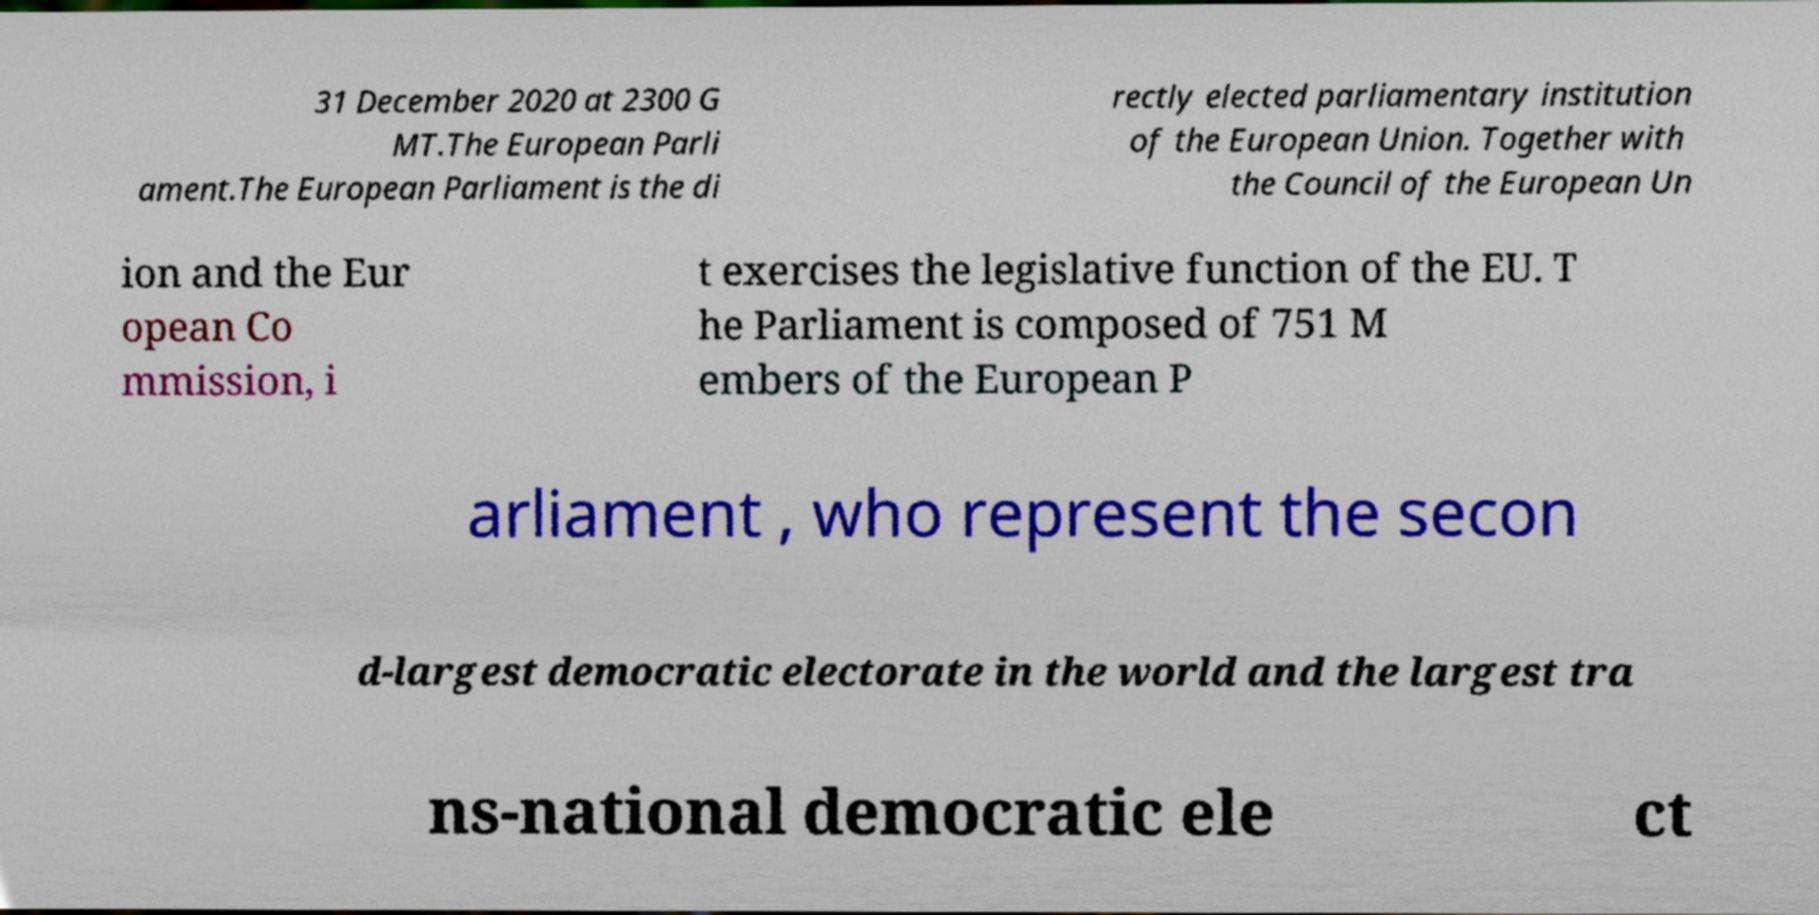Could you assist in decoding the text presented in this image and type it out clearly? 31 December 2020 at 2300 G MT.The European Parli ament.The European Parliament is the di rectly elected parliamentary institution of the European Union. Together with the Council of the European Un ion and the Eur opean Co mmission, i t exercises the legislative function of the EU. T he Parliament is composed of 751 M embers of the European P arliament , who represent the secon d-largest democratic electorate in the world and the largest tra ns-national democratic ele ct 